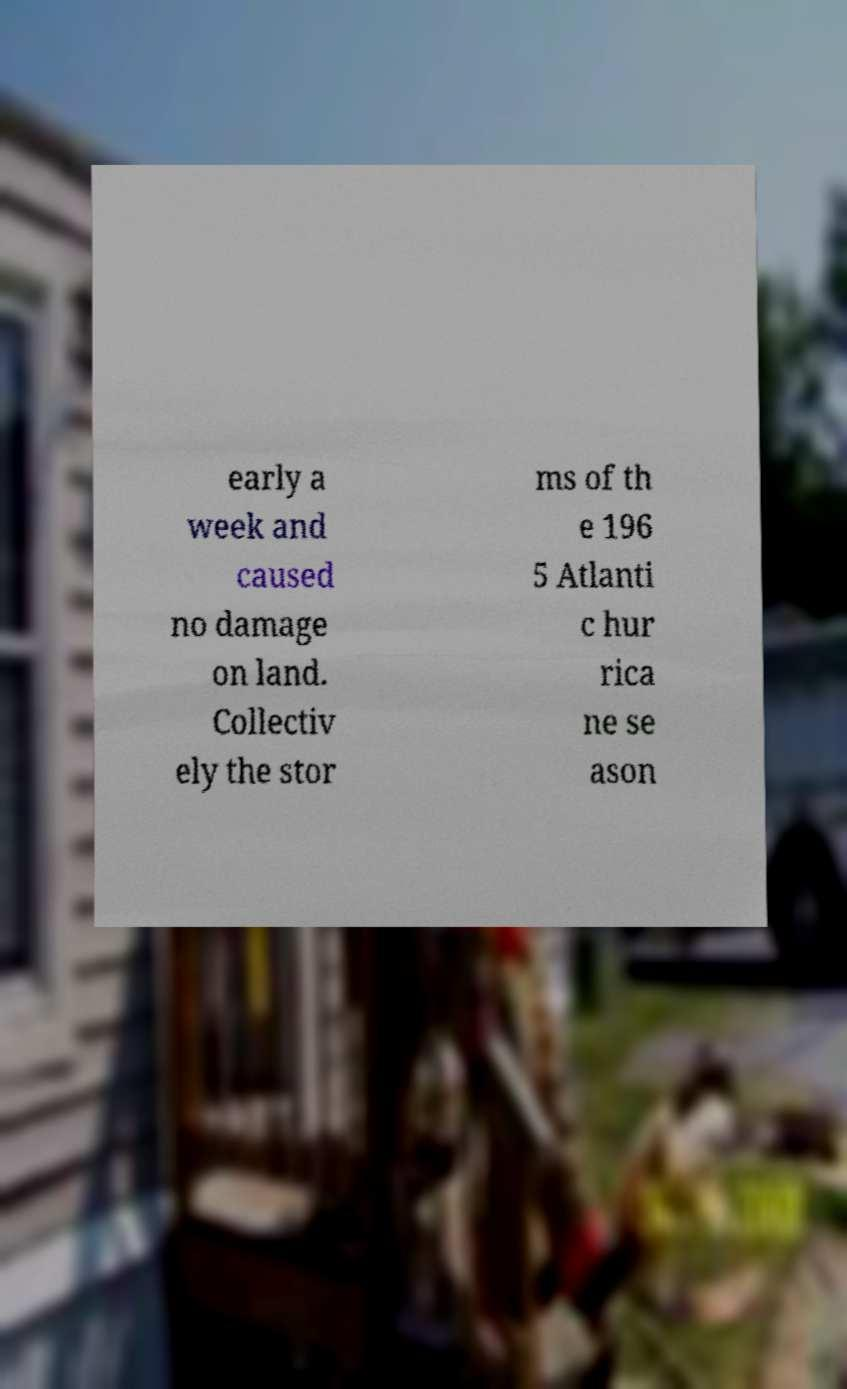Could you assist in decoding the text presented in this image and type it out clearly? early a week and caused no damage on land. Collectiv ely the stor ms of th e 196 5 Atlanti c hur rica ne se ason 